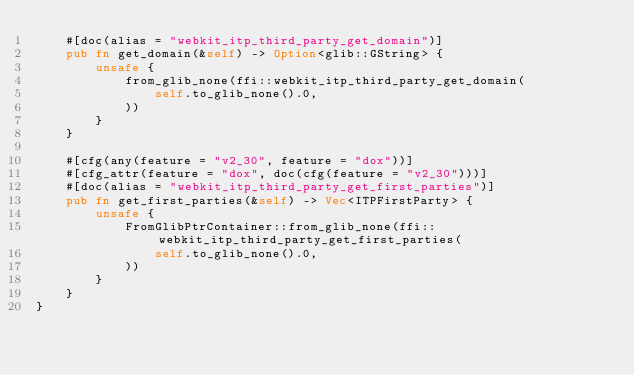<code> <loc_0><loc_0><loc_500><loc_500><_Rust_>    #[doc(alias = "webkit_itp_third_party_get_domain")]
    pub fn get_domain(&self) -> Option<glib::GString> {
        unsafe {
            from_glib_none(ffi::webkit_itp_third_party_get_domain(
                self.to_glib_none().0,
            ))
        }
    }

    #[cfg(any(feature = "v2_30", feature = "dox"))]
    #[cfg_attr(feature = "dox", doc(cfg(feature = "v2_30")))]
    #[doc(alias = "webkit_itp_third_party_get_first_parties")]
    pub fn get_first_parties(&self) -> Vec<ITPFirstParty> {
        unsafe {
            FromGlibPtrContainer::from_glib_none(ffi::webkit_itp_third_party_get_first_parties(
                self.to_glib_none().0,
            ))
        }
    }
}
</code> 